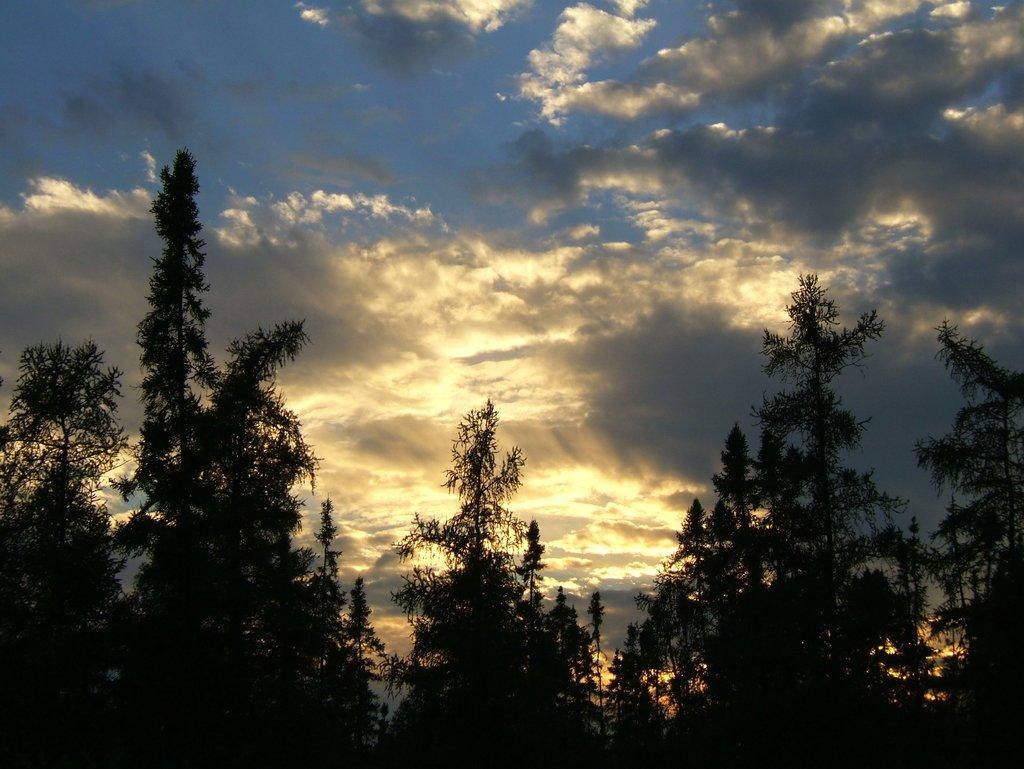Could you give a brief overview of what you see in this image? In the image we can see there are lot of trees and there is a cloudy sky. 